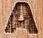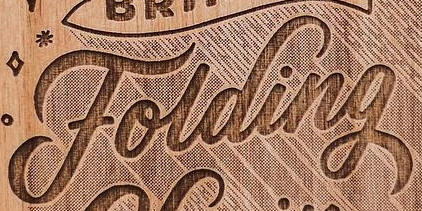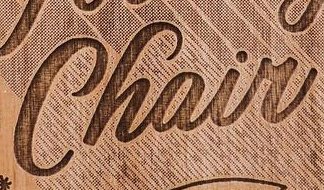Read the text from these images in sequence, separated by a semicolon. A; Folding; Chair 